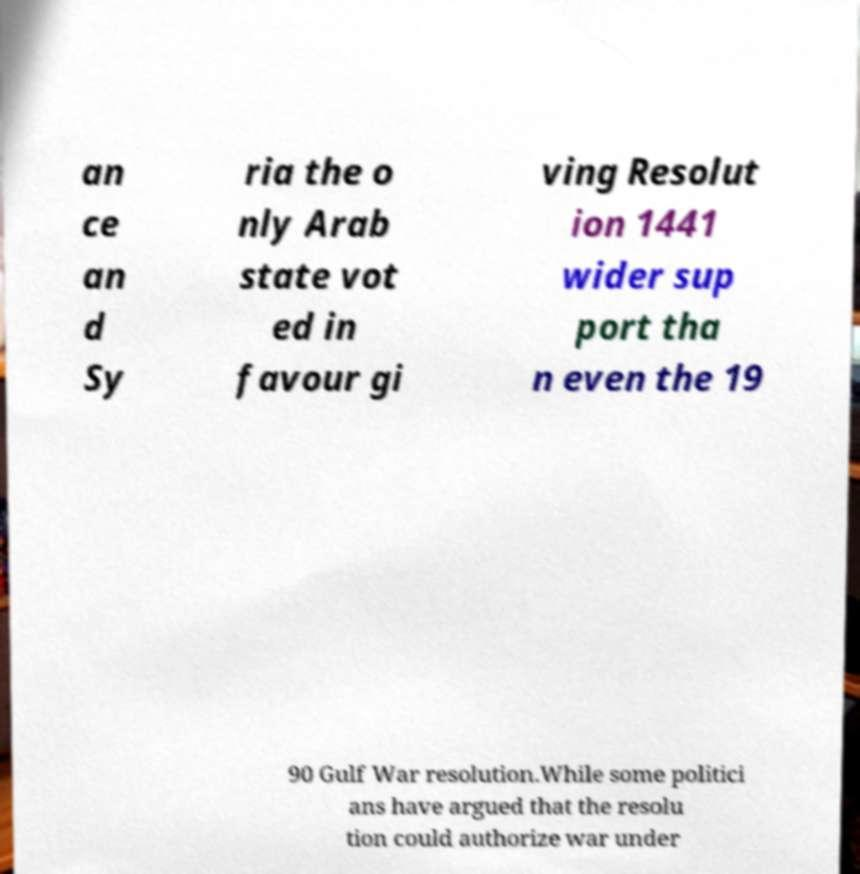Could you assist in decoding the text presented in this image and type it out clearly? an ce an d Sy ria the o nly Arab state vot ed in favour gi ving Resolut ion 1441 wider sup port tha n even the 19 90 Gulf War resolution.While some politici ans have argued that the resolu tion could authorize war under 